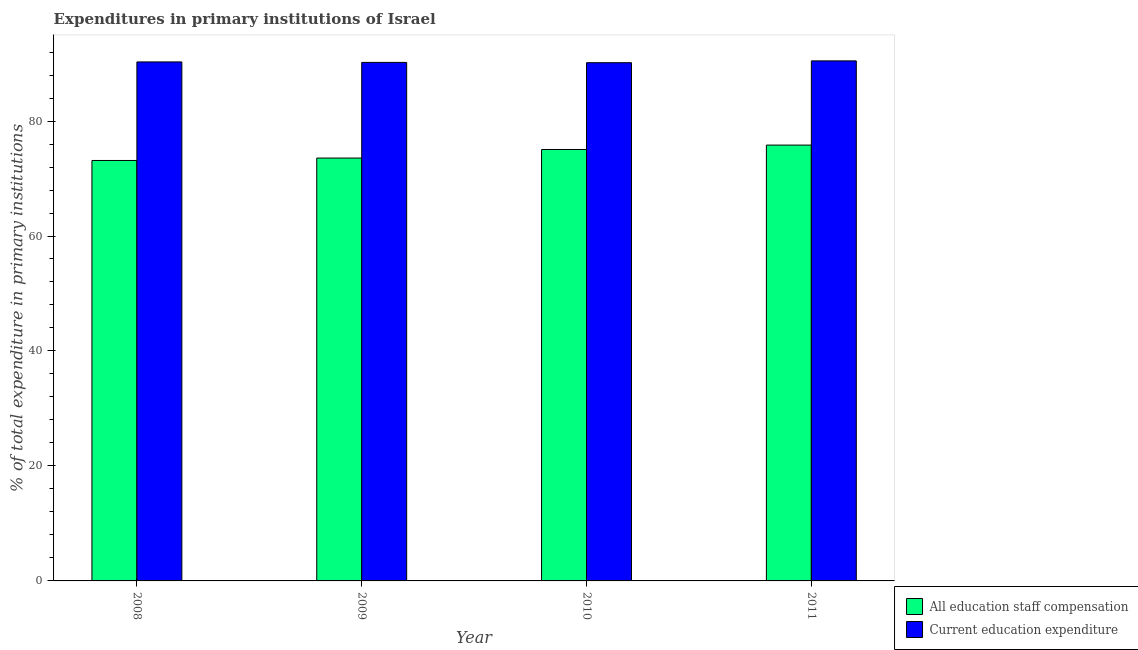Are the number of bars per tick equal to the number of legend labels?
Your response must be concise. Yes. Are the number of bars on each tick of the X-axis equal?
Provide a short and direct response. Yes. How many bars are there on the 1st tick from the right?
Offer a terse response. 2. What is the label of the 1st group of bars from the left?
Provide a succinct answer. 2008. In how many cases, is the number of bars for a given year not equal to the number of legend labels?
Ensure brevity in your answer.  0. What is the expenditure in education in 2011?
Offer a terse response. 90.46. Across all years, what is the maximum expenditure in staff compensation?
Your answer should be compact. 75.82. Across all years, what is the minimum expenditure in education?
Provide a short and direct response. 90.15. What is the total expenditure in staff compensation in the graph?
Make the answer very short. 297.56. What is the difference between the expenditure in staff compensation in 2008 and that in 2011?
Offer a very short reply. -2.68. What is the difference between the expenditure in staff compensation in 2008 and the expenditure in education in 2009?
Make the answer very short. -0.42. What is the average expenditure in education per year?
Ensure brevity in your answer.  90.27. In how many years, is the expenditure in staff compensation greater than 44 %?
Keep it short and to the point. 4. What is the ratio of the expenditure in staff compensation in 2008 to that in 2011?
Give a very brief answer. 0.96. Is the expenditure in education in 2008 less than that in 2009?
Make the answer very short. No. What is the difference between the highest and the second highest expenditure in staff compensation?
Keep it short and to the point. 0.77. What is the difference between the highest and the lowest expenditure in staff compensation?
Ensure brevity in your answer.  2.68. What does the 2nd bar from the left in 2009 represents?
Your response must be concise. Current education expenditure. What does the 2nd bar from the right in 2009 represents?
Provide a succinct answer. All education staff compensation. How many bars are there?
Your response must be concise. 8. Are all the bars in the graph horizontal?
Keep it short and to the point. No. How many years are there in the graph?
Offer a terse response. 4. Where does the legend appear in the graph?
Offer a terse response. Bottom right. How many legend labels are there?
Your response must be concise. 2. How are the legend labels stacked?
Your response must be concise. Vertical. What is the title of the graph?
Make the answer very short. Expenditures in primary institutions of Israel. What is the label or title of the Y-axis?
Keep it short and to the point. % of total expenditure in primary institutions. What is the % of total expenditure in primary institutions in All education staff compensation in 2008?
Offer a terse response. 73.14. What is the % of total expenditure in primary institutions in Current education expenditure in 2008?
Make the answer very short. 90.28. What is the % of total expenditure in primary institutions of All education staff compensation in 2009?
Ensure brevity in your answer.  73.56. What is the % of total expenditure in primary institutions of Current education expenditure in 2009?
Give a very brief answer. 90.2. What is the % of total expenditure in primary institutions of All education staff compensation in 2010?
Provide a short and direct response. 75.05. What is the % of total expenditure in primary institutions in Current education expenditure in 2010?
Make the answer very short. 90.15. What is the % of total expenditure in primary institutions of All education staff compensation in 2011?
Ensure brevity in your answer.  75.82. What is the % of total expenditure in primary institutions in Current education expenditure in 2011?
Keep it short and to the point. 90.46. Across all years, what is the maximum % of total expenditure in primary institutions in All education staff compensation?
Ensure brevity in your answer.  75.82. Across all years, what is the maximum % of total expenditure in primary institutions in Current education expenditure?
Offer a terse response. 90.46. Across all years, what is the minimum % of total expenditure in primary institutions of All education staff compensation?
Your answer should be very brief. 73.14. Across all years, what is the minimum % of total expenditure in primary institutions in Current education expenditure?
Offer a very short reply. 90.15. What is the total % of total expenditure in primary institutions of All education staff compensation in the graph?
Provide a succinct answer. 297.56. What is the total % of total expenditure in primary institutions in Current education expenditure in the graph?
Provide a succinct answer. 361.09. What is the difference between the % of total expenditure in primary institutions of All education staff compensation in 2008 and that in 2009?
Keep it short and to the point. -0.42. What is the difference between the % of total expenditure in primary institutions of Current education expenditure in 2008 and that in 2009?
Provide a succinct answer. 0.08. What is the difference between the % of total expenditure in primary institutions in All education staff compensation in 2008 and that in 2010?
Keep it short and to the point. -1.91. What is the difference between the % of total expenditure in primary institutions in Current education expenditure in 2008 and that in 2010?
Your response must be concise. 0.13. What is the difference between the % of total expenditure in primary institutions of All education staff compensation in 2008 and that in 2011?
Keep it short and to the point. -2.68. What is the difference between the % of total expenditure in primary institutions of Current education expenditure in 2008 and that in 2011?
Your answer should be compact. -0.18. What is the difference between the % of total expenditure in primary institutions of All education staff compensation in 2009 and that in 2010?
Provide a short and direct response. -1.49. What is the difference between the % of total expenditure in primary institutions in Current education expenditure in 2009 and that in 2010?
Provide a short and direct response. 0.05. What is the difference between the % of total expenditure in primary institutions in All education staff compensation in 2009 and that in 2011?
Your answer should be compact. -2.25. What is the difference between the % of total expenditure in primary institutions in Current education expenditure in 2009 and that in 2011?
Provide a succinct answer. -0.27. What is the difference between the % of total expenditure in primary institutions in All education staff compensation in 2010 and that in 2011?
Give a very brief answer. -0.77. What is the difference between the % of total expenditure in primary institutions in Current education expenditure in 2010 and that in 2011?
Provide a succinct answer. -0.32. What is the difference between the % of total expenditure in primary institutions in All education staff compensation in 2008 and the % of total expenditure in primary institutions in Current education expenditure in 2009?
Provide a short and direct response. -17.06. What is the difference between the % of total expenditure in primary institutions in All education staff compensation in 2008 and the % of total expenditure in primary institutions in Current education expenditure in 2010?
Ensure brevity in your answer.  -17.01. What is the difference between the % of total expenditure in primary institutions in All education staff compensation in 2008 and the % of total expenditure in primary institutions in Current education expenditure in 2011?
Offer a very short reply. -17.32. What is the difference between the % of total expenditure in primary institutions of All education staff compensation in 2009 and the % of total expenditure in primary institutions of Current education expenditure in 2010?
Ensure brevity in your answer.  -16.59. What is the difference between the % of total expenditure in primary institutions of All education staff compensation in 2009 and the % of total expenditure in primary institutions of Current education expenditure in 2011?
Ensure brevity in your answer.  -16.9. What is the difference between the % of total expenditure in primary institutions in All education staff compensation in 2010 and the % of total expenditure in primary institutions in Current education expenditure in 2011?
Make the answer very short. -15.42. What is the average % of total expenditure in primary institutions of All education staff compensation per year?
Ensure brevity in your answer.  74.39. What is the average % of total expenditure in primary institutions in Current education expenditure per year?
Provide a succinct answer. 90.27. In the year 2008, what is the difference between the % of total expenditure in primary institutions in All education staff compensation and % of total expenditure in primary institutions in Current education expenditure?
Keep it short and to the point. -17.14. In the year 2009, what is the difference between the % of total expenditure in primary institutions in All education staff compensation and % of total expenditure in primary institutions in Current education expenditure?
Ensure brevity in your answer.  -16.64. In the year 2010, what is the difference between the % of total expenditure in primary institutions in All education staff compensation and % of total expenditure in primary institutions in Current education expenditure?
Your response must be concise. -15.1. In the year 2011, what is the difference between the % of total expenditure in primary institutions of All education staff compensation and % of total expenditure in primary institutions of Current education expenditure?
Offer a terse response. -14.65. What is the ratio of the % of total expenditure in primary institutions in All education staff compensation in 2008 to that in 2009?
Make the answer very short. 0.99. What is the ratio of the % of total expenditure in primary institutions of Current education expenditure in 2008 to that in 2009?
Keep it short and to the point. 1. What is the ratio of the % of total expenditure in primary institutions in All education staff compensation in 2008 to that in 2010?
Your answer should be very brief. 0.97. What is the ratio of the % of total expenditure in primary institutions of All education staff compensation in 2008 to that in 2011?
Provide a short and direct response. 0.96. What is the ratio of the % of total expenditure in primary institutions of All education staff compensation in 2009 to that in 2010?
Your answer should be very brief. 0.98. What is the ratio of the % of total expenditure in primary institutions of Current education expenditure in 2009 to that in 2010?
Provide a short and direct response. 1. What is the ratio of the % of total expenditure in primary institutions in All education staff compensation in 2009 to that in 2011?
Your response must be concise. 0.97. What is the ratio of the % of total expenditure in primary institutions of Current education expenditure in 2010 to that in 2011?
Your response must be concise. 1. What is the difference between the highest and the second highest % of total expenditure in primary institutions in All education staff compensation?
Offer a very short reply. 0.77. What is the difference between the highest and the second highest % of total expenditure in primary institutions of Current education expenditure?
Offer a terse response. 0.18. What is the difference between the highest and the lowest % of total expenditure in primary institutions in All education staff compensation?
Give a very brief answer. 2.68. What is the difference between the highest and the lowest % of total expenditure in primary institutions in Current education expenditure?
Your answer should be very brief. 0.32. 